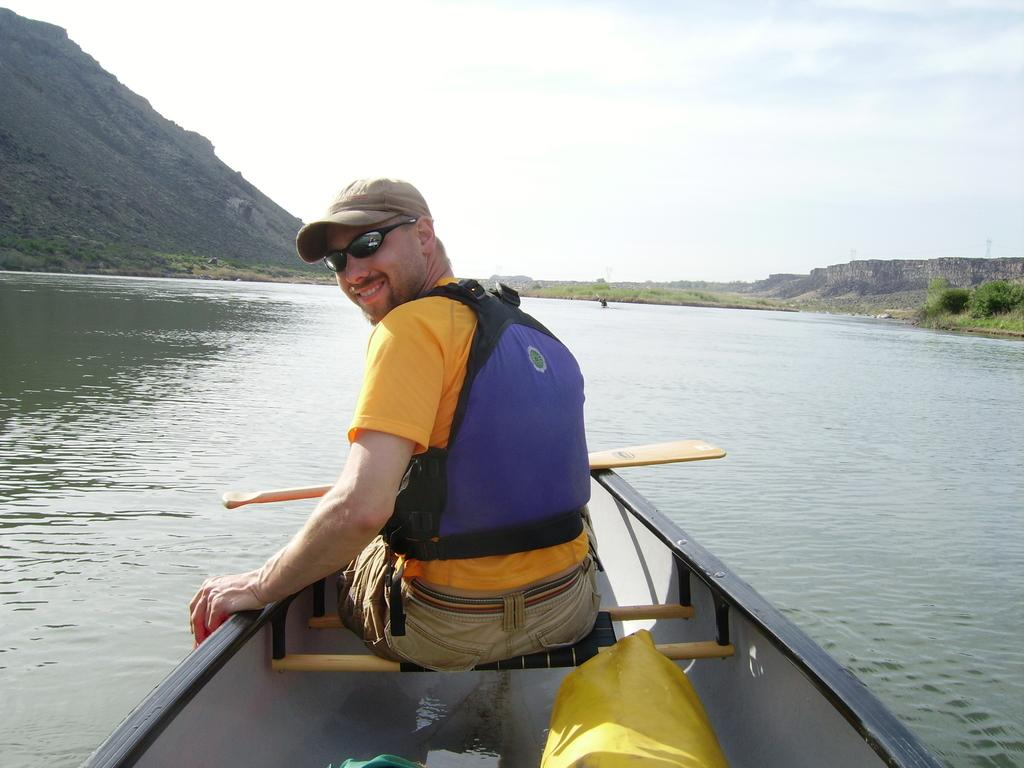What is the man in the image doing? The man is sitting in a boat. Where is the boat located? The boat is on water. What can be seen in the background of the image? The sky is visible in the image. How many oranges are floating in the water next to the boat? There are no oranges visible in the image; the man is sitting in a boat on water. 